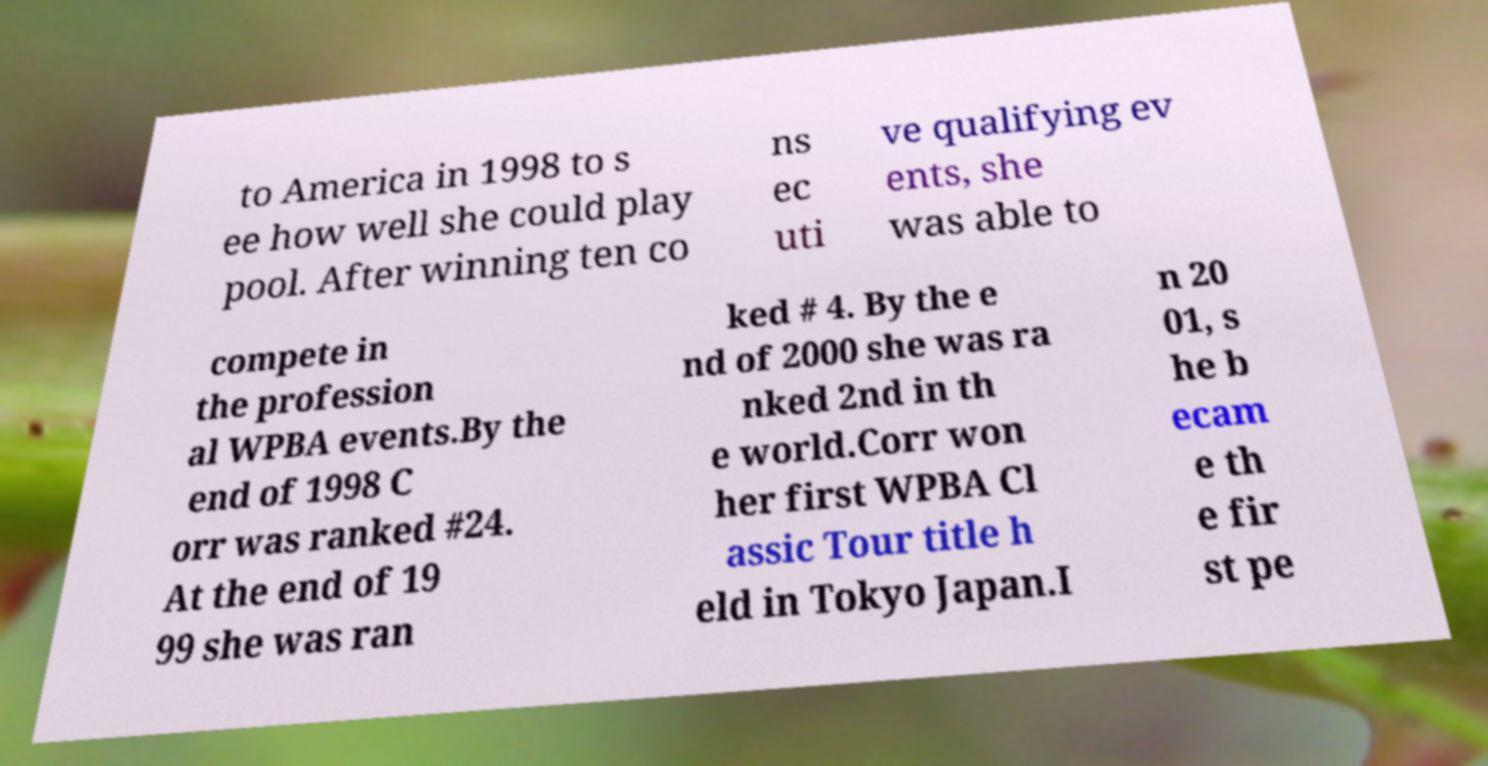For documentation purposes, I need the text within this image transcribed. Could you provide that? to America in 1998 to s ee how well she could play pool. After winning ten co ns ec uti ve qualifying ev ents, she was able to compete in the profession al WPBA events.By the end of 1998 C orr was ranked #24. At the end of 19 99 she was ran ked # 4. By the e nd of 2000 she was ra nked 2nd in th e world.Corr won her first WPBA Cl assic Tour title h eld in Tokyo Japan.I n 20 01, s he b ecam e th e fir st pe 